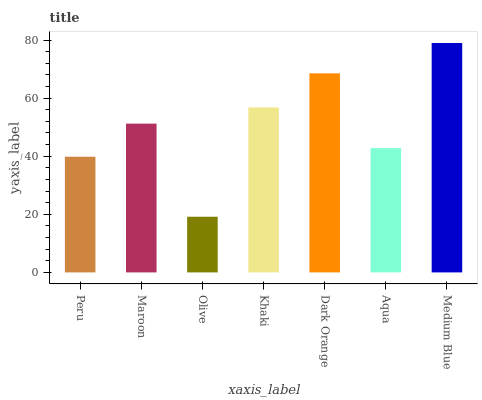Is Olive the minimum?
Answer yes or no. Yes. Is Medium Blue the maximum?
Answer yes or no. Yes. Is Maroon the minimum?
Answer yes or no. No. Is Maroon the maximum?
Answer yes or no. No. Is Maroon greater than Peru?
Answer yes or no. Yes. Is Peru less than Maroon?
Answer yes or no. Yes. Is Peru greater than Maroon?
Answer yes or no. No. Is Maroon less than Peru?
Answer yes or no. No. Is Maroon the high median?
Answer yes or no. Yes. Is Maroon the low median?
Answer yes or no. Yes. Is Medium Blue the high median?
Answer yes or no. No. Is Peru the low median?
Answer yes or no. No. 